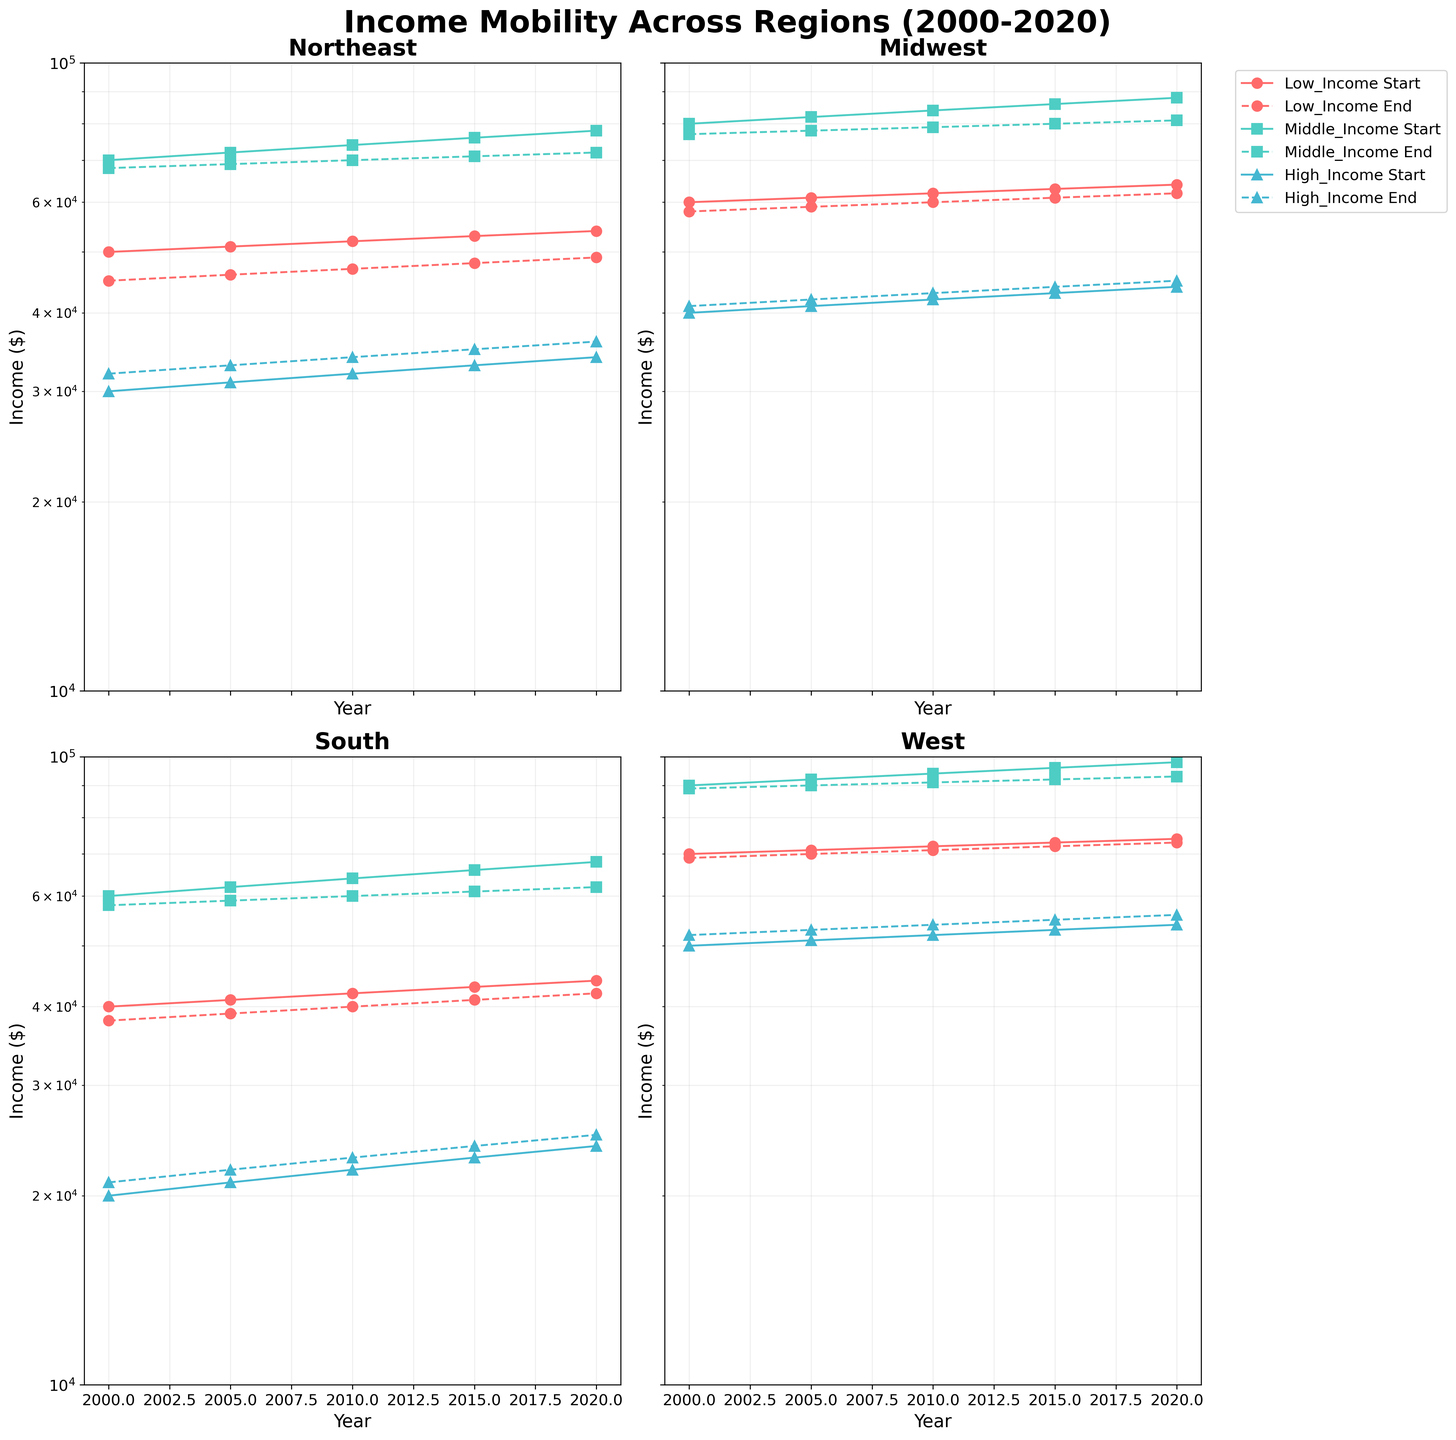What is the title of the figure? The title is located at the top of the figure in a larger font size compared to other texts. It reads "Income Mobility Across Regions (2000-2020)".
Answer: Income Mobility Across Regions (2000-2020) What does a dashed line represent on the plot? From the legend, a dashed line represents the 'End' value for each income group in a given region.
Answer: End value Which region shows the lowest low-income start value in 2020? In the 2020 column, 'South' has the lowest low-income start value at 44000, compared to other regions like Northeast, Midwest, and West.
Answer: South Which region experienced the greatest increase in high-income start value from 2000 to 2020? By comparing the high-income start values from 2000 to 2020 for each region, we see that 'West' increased from 50000 to 54000 whereas other regions have smaller increments.
Answer: West What is the log scale's lower and upper limit for the y-axis in these subplots? The y-axis has a logarithmic scale with values ranging from 10000 to 100000. This can be seen by observing the axis ticks.
Answer: 10000, 100000 Which income group shows the smallest mobility in the Midwest region from 2000 to 2020? By looking at the plot for the Midwest, the change in values (both start and end) for 'High Income' seems the smallest compared to 'Low Income' and 'Middle Income'.
Answer: High Income Between Northeast and Midwest, which region had a higher middle-income end value in 2010? Comparing both subplots for 2010, the 'Northeast' has a middle-income end value of 70000, while 'Midwest' has 79000 for the same year.
Answer: Midwest How would you describe the trend in high-income end value in the South region from 2000 to 2020? Observing the subplot for the South, the high-income end values start at 21000 in 2000 and gradually increase to 25000 by 2020. The trend shows a consistent upward movement.
Answer: Gradual increase Is there a region where the low-income end value increased over the years 2000 to 2020? In all four regions, the low-income end values see an increase from 2000 to 2020. For example, Northeast's low-income end value rises from 45000 to 49000.
Answer: Yes Which region has the steepest slope in the middle-income start values? Looking at the middle-income start values across the regions, 'West' appears to have the steepest slope considering its values rise from 90000 to 98000 from 2000 to 2020.
Answer: West 